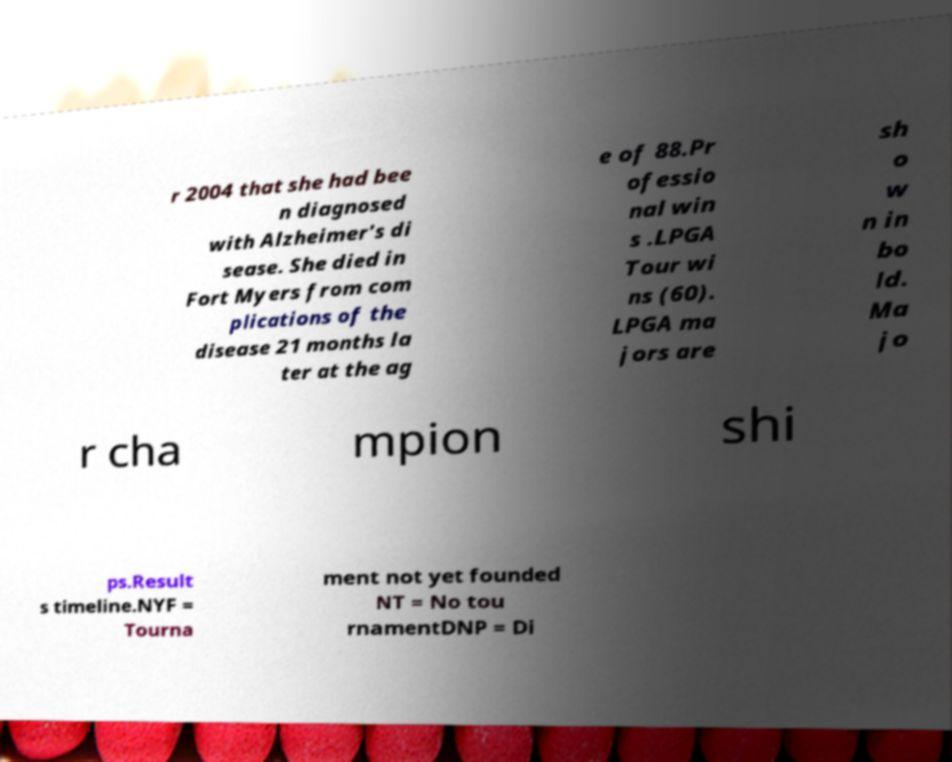For documentation purposes, I need the text within this image transcribed. Could you provide that? r 2004 that she had bee n diagnosed with Alzheimer's di sease. She died in Fort Myers from com plications of the disease 21 months la ter at the ag e of 88.Pr ofessio nal win s .LPGA Tour wi ns (60). LPGA ma jors are sh o w n in bo ld. Ma jo r cha mpion shi ps.Result s timeline.NYF = Tourna ment not yet founded NT = No tou rnamentDNP = Di 